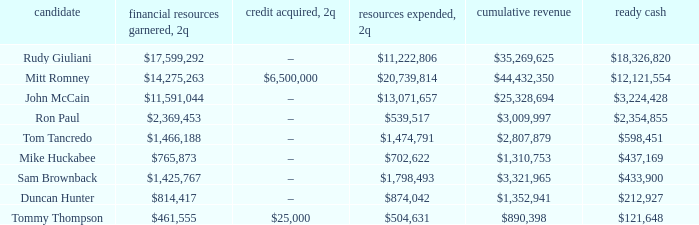Inform me of the funds collected when 2q has total revenues of $890,39 $461,555. 